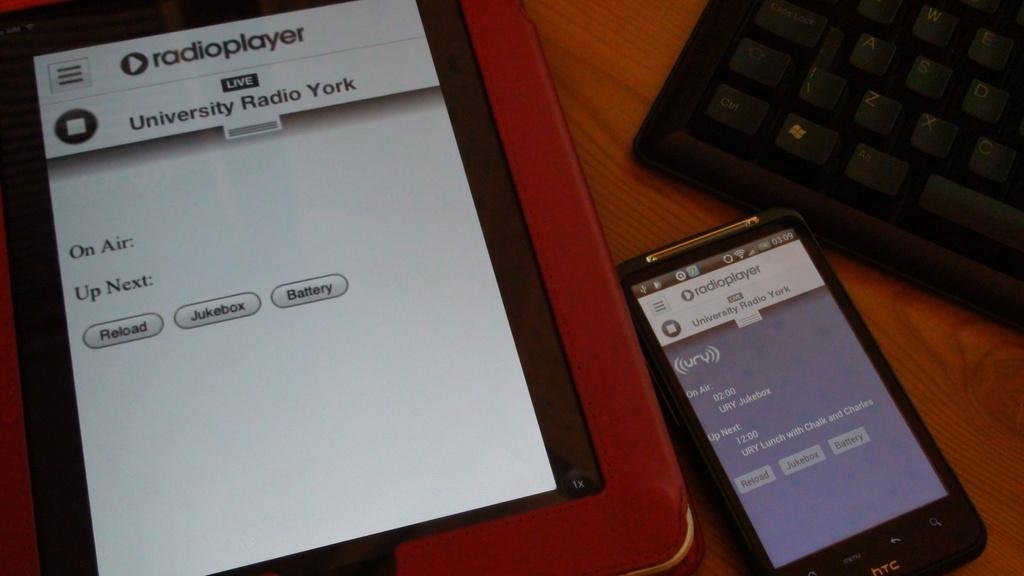<image>
Give a short and clear explanation of the subsequent image. A tablet and a smartphone are shown with an app called radioplayer open. 